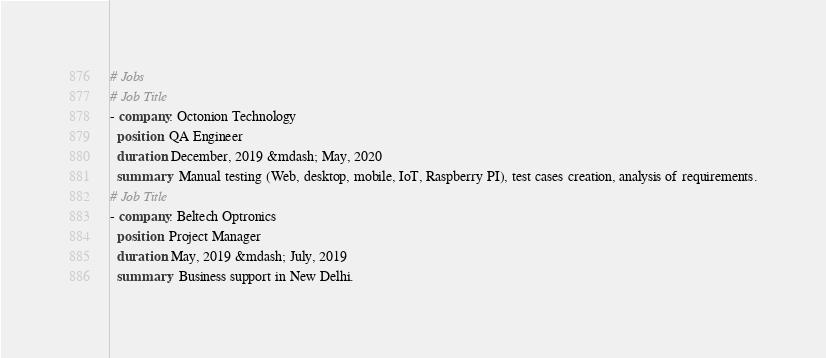Convert code to text. <code><loc_0><loc_0><loc_500><loc_500><_YAML_># Jobs
# Job Title
- company: Octonion Technology
  position: QA Engineer
  duration: December, 2019 &mdash; May, 2020
  summary:  Manual testing (Web, desktop, mobile, IoT, Raspberry PI), test cases creation, analysis of requirements.
# Job Title
- company: Beltech Optronics
  position: Project Manager
  duration: May, 2019 &mdash; July, 2019
  summary:  Business support in New Delhi.
</code> 